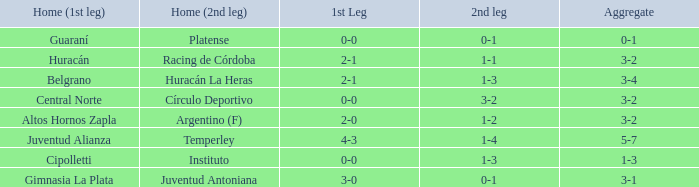Which team played their first leg at home with an aggregate score of 3-4? Belgrano. 